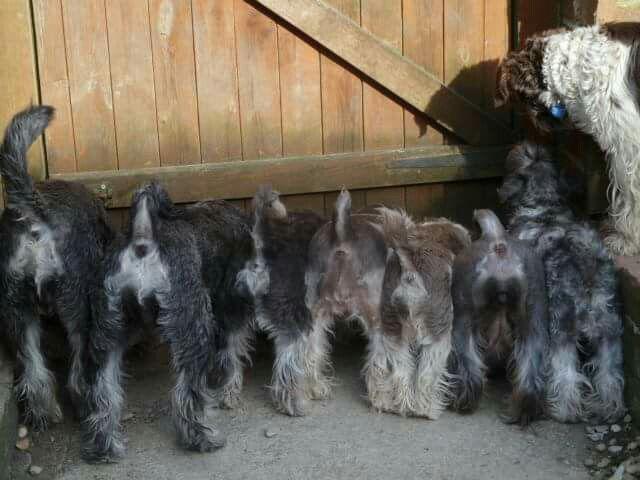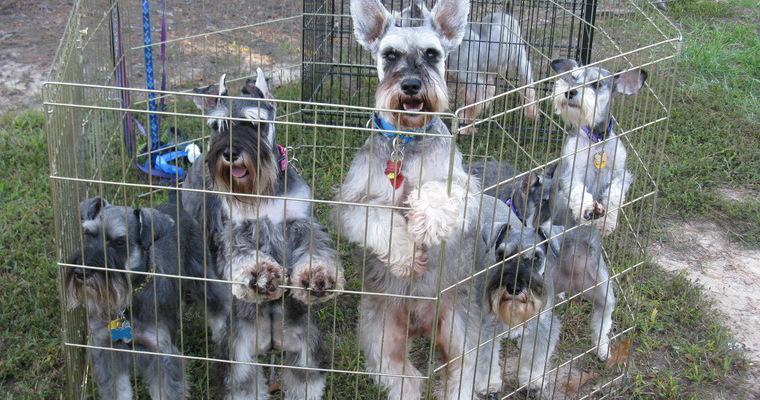The first image is the image on the left, the second image is the image on the right. Analyze the images presented: Is the assertion "There are two dogs in total." valid? Answer yes or no. No. 